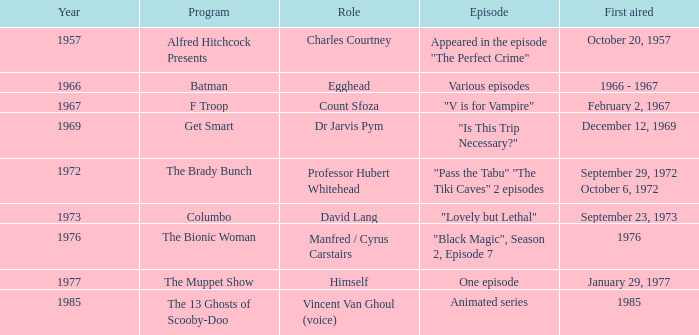What's the first aired date when Professor Hubert Whitehead was the role? September 29, 1972 October 6, 1972. 